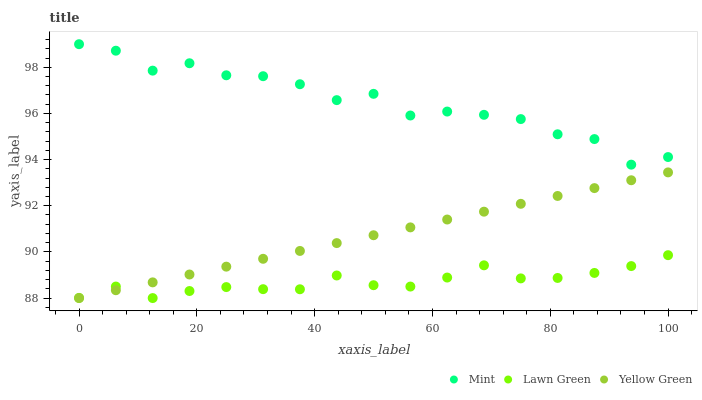Does Lawn Green have the minimum area under the curve?
Answer yes or no. Yes. Does Mint have the maximum area under the curve?
Answer yes or no. Yes. Does Yellow Green have the minimum area under the curve?
Answer yes or no. No. Does Yellow Green have the maximum area under the curve?
Answer yes or no. No. Is Yellow Green the smoothest?
Answer yes or no. Yes. Is Mint the roughest?
Answer yes or no. Yes. Is Mint the smoothest?
Answer yes or no. No. Is Yellow Green the roughest?
Answer yes or no. No. Does Lawn Green have the lowest value?
Answer yes or no. Yes. Does Mint have the lowest value?
Answer yes or no. No. Does Mint have the highest value?
Answer yes or no. Yes. Does Yellow Green have the highest value?
Answer yes or no. No. Is Lawn Green less than Mint?
Answer yes or no. Yes. Is Mint greater than Lawn Green?
Answer yes or no. Yes. Does Yellow Green intersect Lawn Green?
Answer yes or no. Yes. Is Yellow Green less than Lawn Green?
Answer yes or no. No. Is Yellow Green greater than Lawn Green?
Answer yes or no. No. Does Lawn Green intersect Mint?
Answer yes or no. No. 